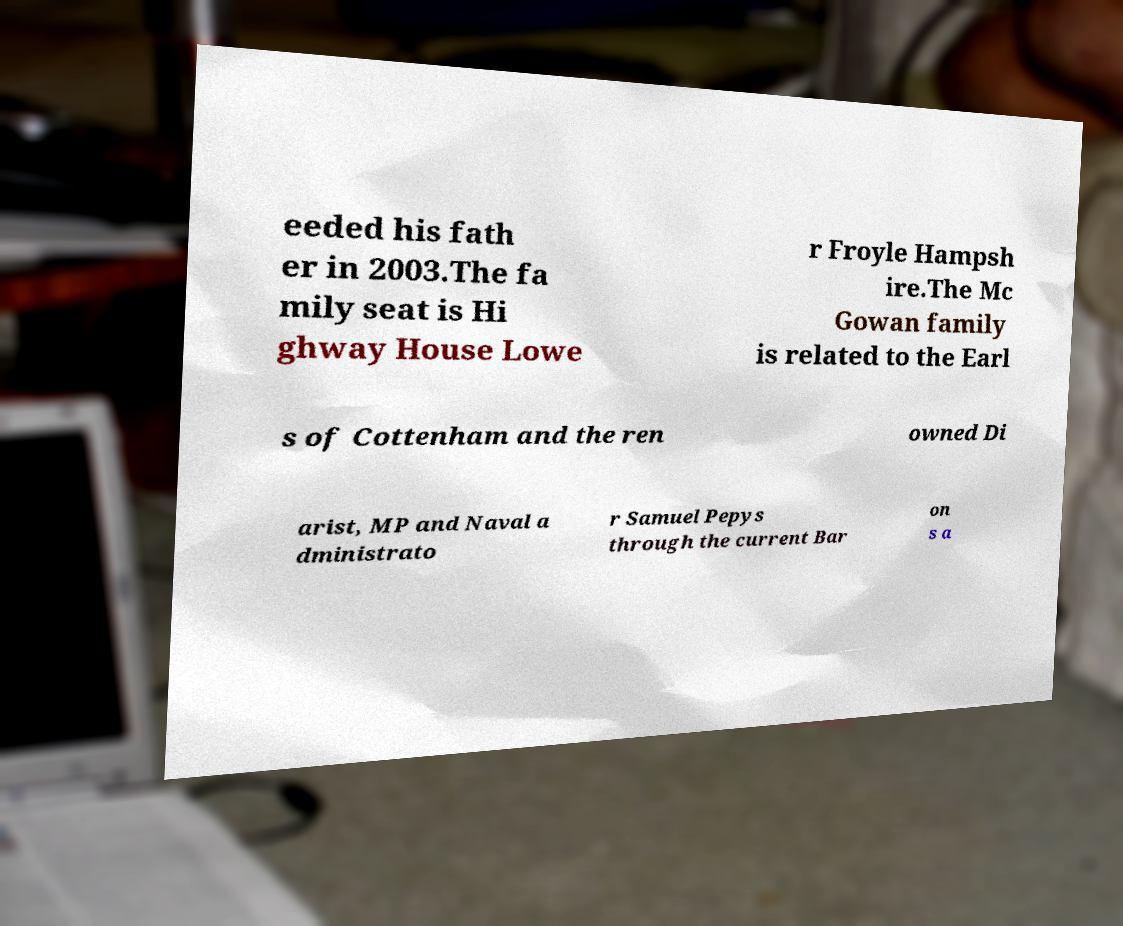There's text embedded in this image that I need extracted. Can you transcribe it verbatim? eeded his fath er in 2003.The fa mily seat is Hi ghway House Lowe r Froyle Hampsh ire.The Mc Gowan family is related to the Earl s of Cottenham and the ren owned Di arist, MP and Naval a dministrato r Samuel Pepys through the current Bar on s a 